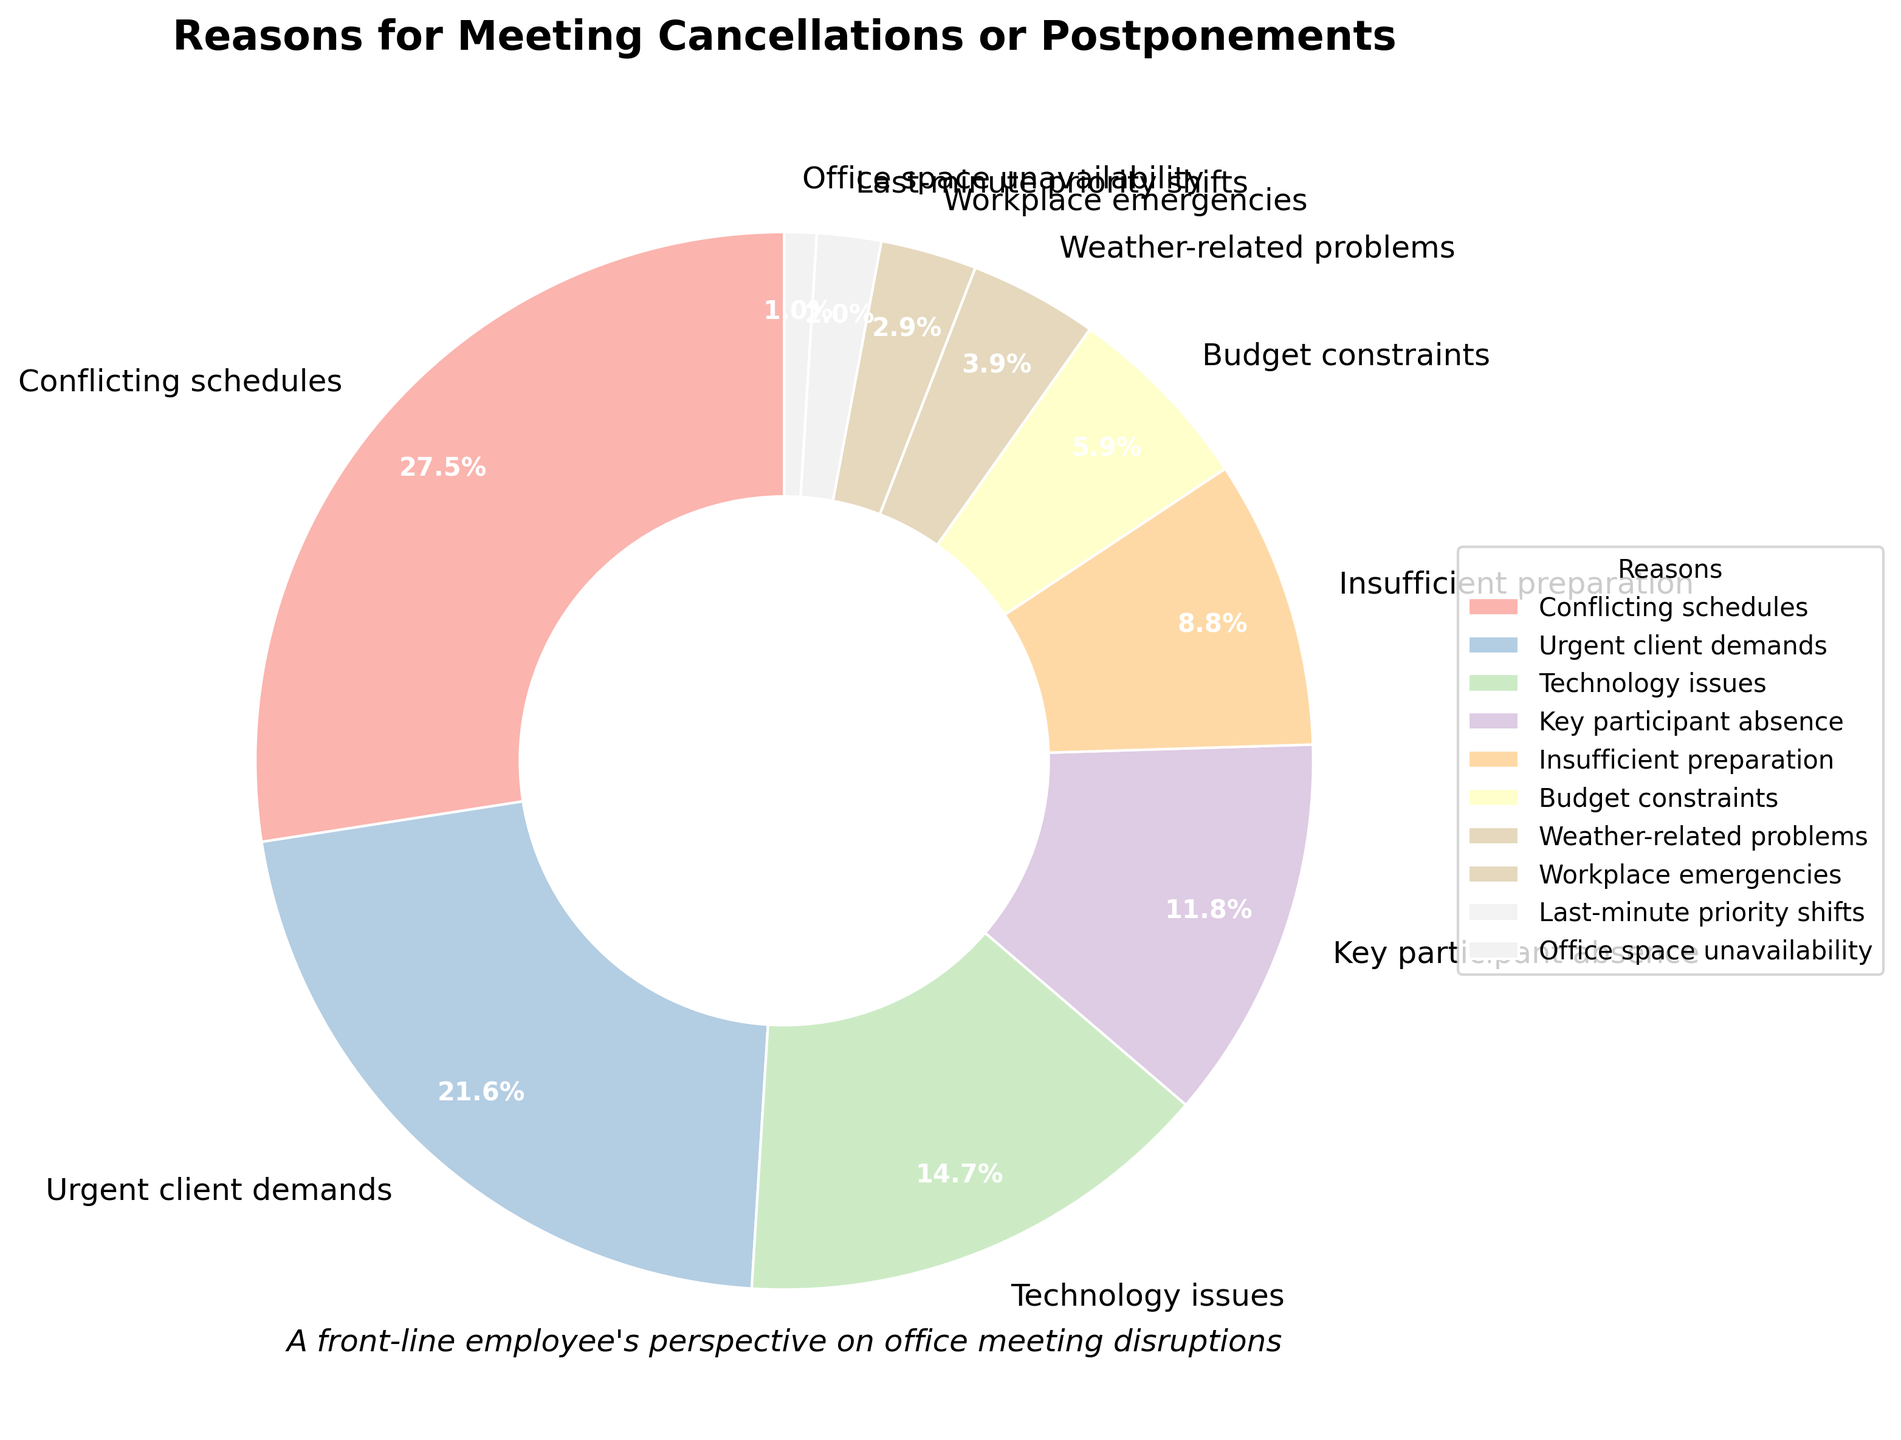Which reason accounts for the largest percentage of meeting cancellations or postponements? To find the reason with the largest percentage, observe the pie chart and identify the segment with the biggest area. The percentage shown on that segment will indicate which reason is the most significant.
Answer: Conflicting schedules What is the combined percentage of meeting cancellations or postponements due to "Urgent client demands" and "Technology issues"? Look at the pie chart and identify the segments for "Urgent client demands" (22%) and "Technology issues" (15%). Then, add these percentages together: 22% + 15% = 37%.
Answer: 37% Which is more common, "Insufficient preparation" or "Key participant absence"? Compare the percentages for "Insufficient preparation" (9%) and "Key participant absence" (12%) by looking at their respective segments on the chart.
Answer: Key participant absence What is the difference in the percentage of meeting cancellations between "Budget constraints" and "Weather-related problems"? Identify the segments in the pie chart for "Budget constraints" (6%) and "Weather-related problems" (4%). Then, subtract the smaller percentage from the larger one: 6% - 4% = 2%.
Answer: 2% How many reasons listed account for less than 10% of meeting cancellations or postponements? Examine the pie chart and count the segments with percentages less than 10%. These include "Insufficient preparation" (9%), "Budget constraints" (6%), "Weather-related problems" (4%), "Workplace emergencies" (3%), "Last-minute priority shifts" (2%), and "Office space unavailability" (1%).
Answer: 6 Summarize the three least common reasons for meeting cancellations or postponements. Identify the three smallest segments on the pie chart. The segments showing "Office space unavailability" (1%), "Last-minute priority shifts" (2%), and "Workplace emergencies" (3%) are the least common reasons.
Answer: Office space unavailability, Last-minute priority shifts, Workplace emergencies What's the total percentage of meeting cancellations caused by issues that can be considered external (like "Weather-related problems" and "Workplace emergencies")? Identify the segments for external issues: "Weather-related problems" (4%) and "Workplace emergencies" (3%). Then, sum these percentages: 4% + 3% = 7%.
Answer: 7% Is "Conflicting schedules" responsible for more than double the percentage of cancellations compared to "Key participant absence"? Observe the pie chart for "Conflicting schedules" (28%) and "Key participant absence" (12%). Check if 28% is more than twice 12%. Yes, 28% > 2 * 12%.
Answer: Yes Which reason contributes less than 5% to meeting cancellations? Look for segments with percentages less than 5% on the pie chart. "Weather-related problems" (4%), "Workplace emergencies" (3%), "Last-minute priority shifts" (2%), and "Office space unavailability" (1%) fit this criterion.
Answer: Weather-related problems, Workplace emergencies, Last-minute priority shifts, Office space unavailability 